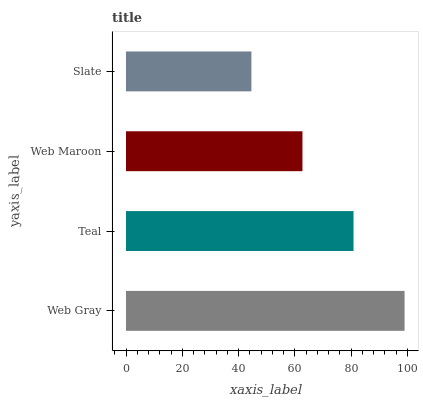Is Slate the minimum?
Answer yes or no. Yes. Is Web Gray the maximum?
Answer yes or no. Yes. Is Teal the minimum?
Answer yes or no. No. Is Teal the maximum?
Answer yes or no. No. Is Web Gray greater than Teal?
Answer yes or no. Yes. Is Teal less than Web Gray?
Answer yes or no. Yes. Is Teal greater than Web Gray?
Answer yes or no. No. Is Web Gray less than Teal?
Answer yes or no. No. Is Teal the high median?
Answer yes or no. Yes. Is Web Maroon the low median?
Answer yes or no. Yes. Is Web Maroon the high median?
Answer yes or no. No. Is Slate the low median?
Answer yes or no. No. 